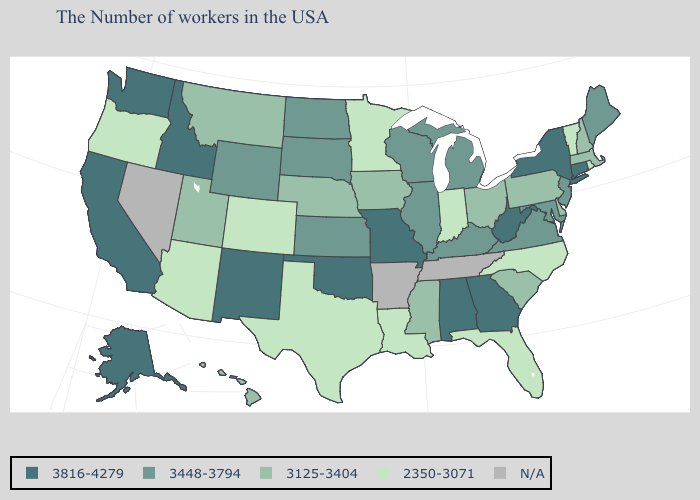What is the value of Washington?
Be succinct. 3816-4279. What is the lowest value in the West?
Quick response, please. 2350-3071. Name the states that have a value in the range 3448-3794?
Be succinct. Maine, New Jersey, Maryland, Virginia, Michigan, Kentucky, Wisconsin, Illinois, Kansas, South Dakota, North Dakota, Wyoming. What is the value of Wisconsin?
Concise answer only. 3448-3794. What is the highest value in the West ?
Write a very short answer. 3816-4279. What is the value of Michigan?
Be succinct. 3448-3794. Name the states that have a value in the range N/A?
Give a very brief answer. Tennessee, Arkansas, Nevada. What is the value of Texas?
Short answer required. 2350-3071. Name the states that have a value in the range 3125-3404?
Write a very short answer. Massachusetts, New Hampshire, Delaware, Pennsylvania, South Carolina, Ohio, Mississippi, Iowa, Nebraska, Utah, Montana, Hawaii. Which states have the highest value in the USA?
Keep it brief. Connecticut, New York, West Virginia, Georgia, Alabama, Missouri, Oklahoma, New Mexico, Idaho, California, Washington, Alaska. Name the states that have a value in the range 3816-4279?
Keep it brief. Connecticut, New York, West Virginia, Georgia, Alabama, Missouri, Oklahoma, New Mexico, Idaho, California, Washington, Alaska. What is the value of New York?
Keep it brief. 3816-4279. Among the states that border Montana , which have the lowest value?
Quick response, please. South Dakota, North Dakota, Wyoming. 